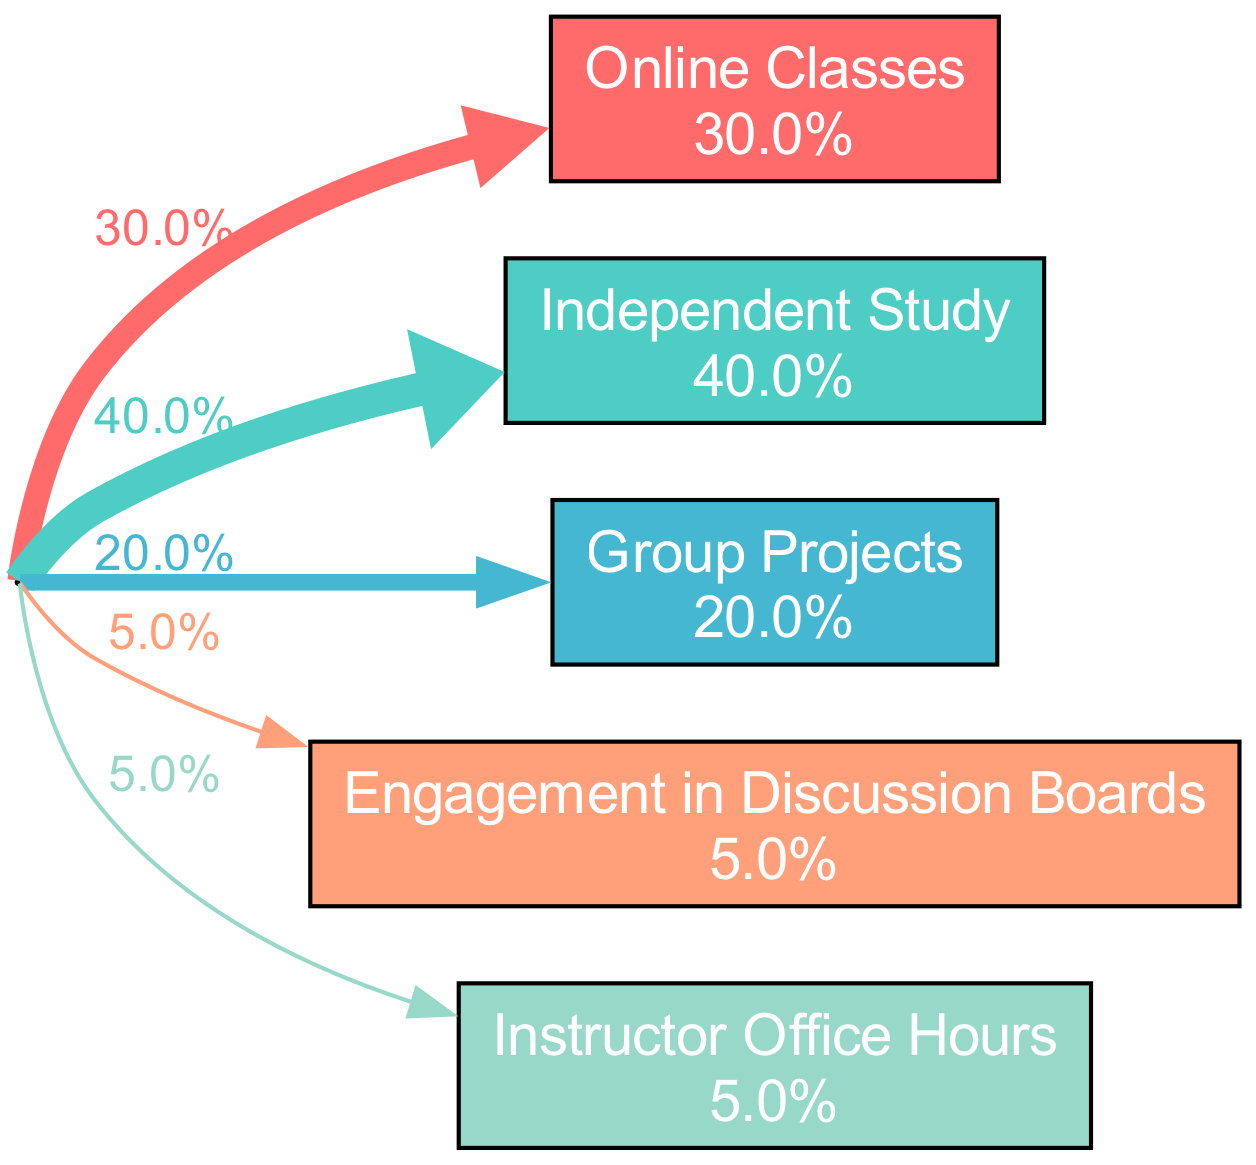What percentage of time do students spend on Online Classes? The diagram indicates that Online Classes constitute 30% of the total time allocation for students. This is directly stated in the activity description on the respective node.
Answer: 30% What activity has the highest duration? By comparing the percentage durations in the diagram, Independent Study at 40% is the highest of all activities listed. This can be observed by identifying and comparing the values for each activity.
Answer: Independent Study How many different activities are represented in the diagram? The diagram has a total of five distinct activities represented as nodes, which can be counted directly from the visible entries in the diagram.
Answer: 5 What percentage of time is allocated to Engagement in Discussion Boards? From the diagram, we can see that Engagement in Discussion Boards accounts for 5% of the overall time allocation for students, as stated in the specific activity node.
Answer: 5% Which activities combined account for at least 60% of the total time? By adding up the percentages, Independent Study (40%) and Online Classes (30%) combine to account for 70%, exceeding the 60% threshold. This is determined by summing the percentages of the two highest activities.
Answer: Independent Study and Online Classes How much more time is allocated to Independent Study than to Group Projects? The difference can be calculated as 40% for Independent Study minus 20% for Group Projects, resulting in a 20% higher allocation for Independent Study. This is derived by directly comparing the percentage values for both activities.
Answer: 20% What is the total duration percentage of time spent on Group Projects and Engagement in Discussion Boards combined? The total for these two activities is calculated as 20% for Group Projects plus 5% for Engagement in Discussion Boards, resulting in a total of 25%. This involves simple addition of the two specified percentages.
Answer: 25% How are the activities visually represented in terms of flow from the starting point? The activities are connected to the starting point by edges that reflect the percentage of time allocated to each activity, visually represented by the width of the edges, with wider edges corresponding to higher percentages. This demonstrates how flows differ in size according to their allocated time.
Answer: By width of edges What can be inferred about the time students spend on Instructor Office Hours compared to Engagement in Discussion Boards? Both activities have the same percentage allocation of 5%, indicating that students devote equal amounts of time to both activities. This can be concluded from the percentage values shown in the respective nodes for these activities.
Answer: Equal time 